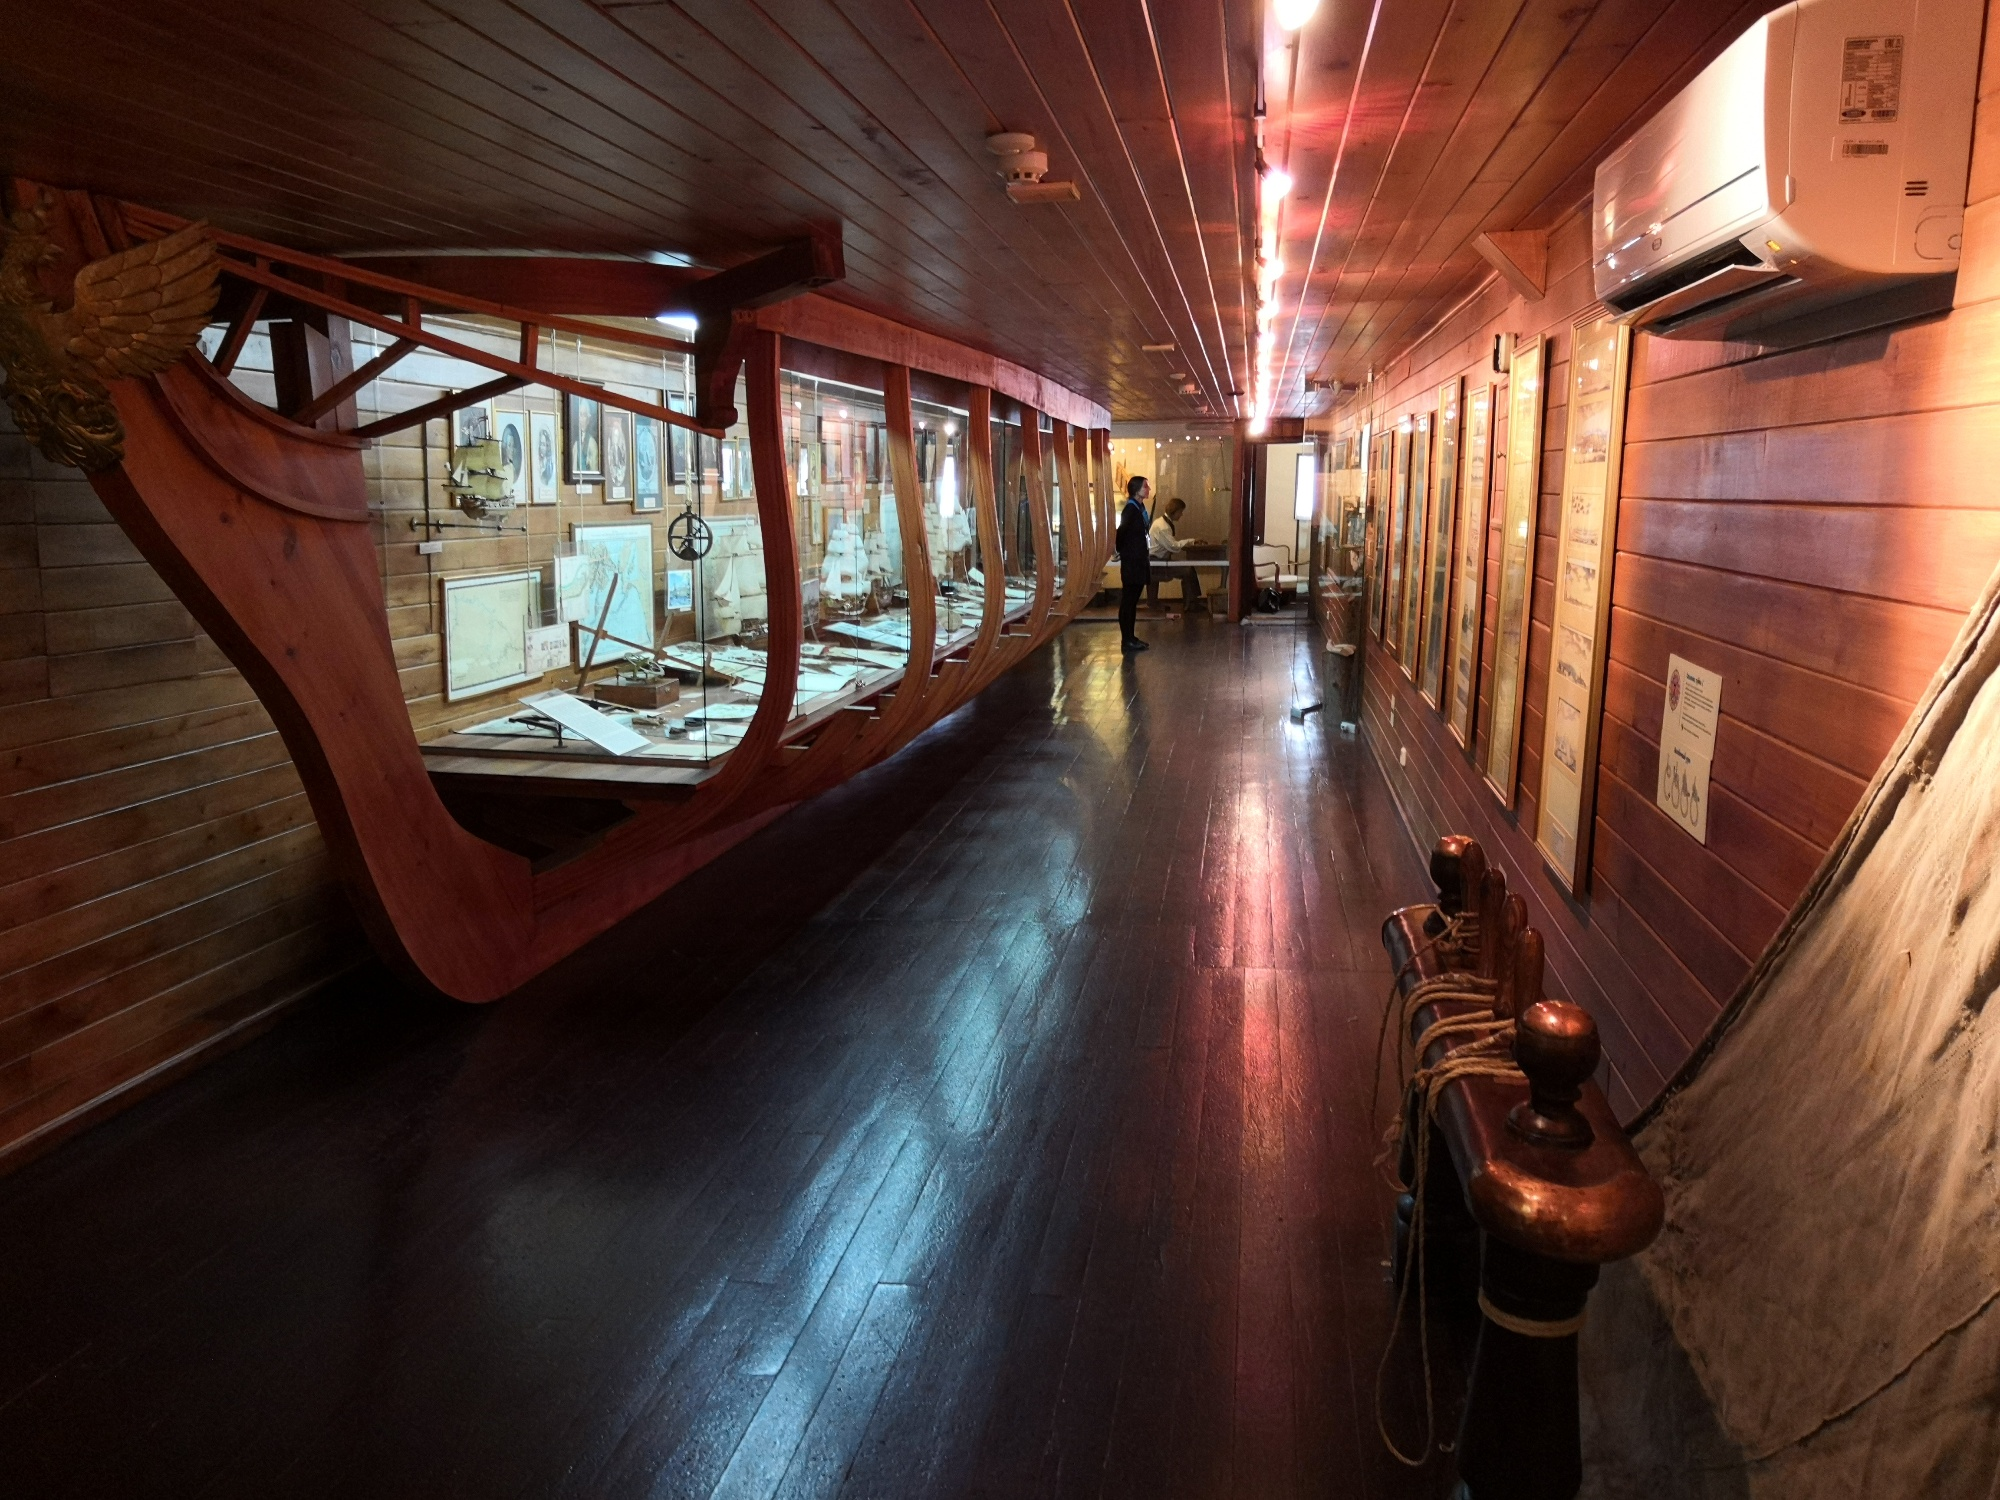If these walls could talk, what stories might they tell? If these walls could talk, they would recount the epic tales of bravery and discovery during the Age of Exploration. They would speak of the painstaking effort involved in the construction of ships like the Santa Maria, crafted from sturdy timbers to brave the treacherous Atlantic waters. Each artifact would narrate its own story: a compass that once pointed the way through fog and storm, maps that traced the first encounters with unknown lands, and the tools that built and maintained seafaring vessels. They would tell of the sailors' hopes, fears, and the thrill of the open sea, alongside the perils of navigation and the drive to explore beyond the known horizon. These walls would echo with the voices of past explorers, invigorated by the call of adventure and the quest for new worlds. 